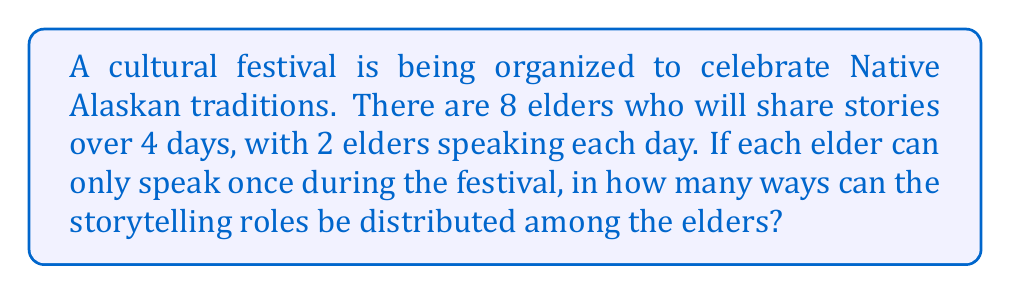What is the answer to this math problem? Let's approach this step-by-step:

1) This is a combination problem where we need to select 2 elders for each of the 4 days from a total of 8 elders.

2) We can solve this using the multiplication principle and combinations.

3) For the first day:
   We need to choose 2 elders from 8. This can be done in $\binom{8}{2}$ ways.
   $$\binom{8}{2} = \frac{8!}{2!(8-2)!} = \frac{8 \cdot 7}{2 \cdot 1} = 28$$

4) For the second day:
   We now have 6 elders left, and need to choose 2. This can be done in $\binom{6}{2}$ ways.
   $$\binom{6}{2} = \frac{6!}{2!(6-2)!} = \frac{6 \cdot 5}{2 \cdot 1} = 15$$

5) For the third day:
   We have 4 elders left, and need to choose 2. This can be done in $\binom{4}{2}$ ways.
   $$\binom{4}{2} = \frac{4!}{2!(4-2)!} = \frac{4 \cdot 3}{2 \cdot 1} = 6$$

6) For the last day:
   We have 2 elders left, which is exactly how many we need. This can be done in $\binom{2}{2} = 1$ way.

7) By the multiplication principle, the total number of ways to distribute the storytelling roles is:
   $$28 \cdot 15 \cdot 6 \cdot 1 = 2,520$$

Therefore, there are 2,520 ways to distribute the storytelling roles among the elders.
Answer: 2,520 